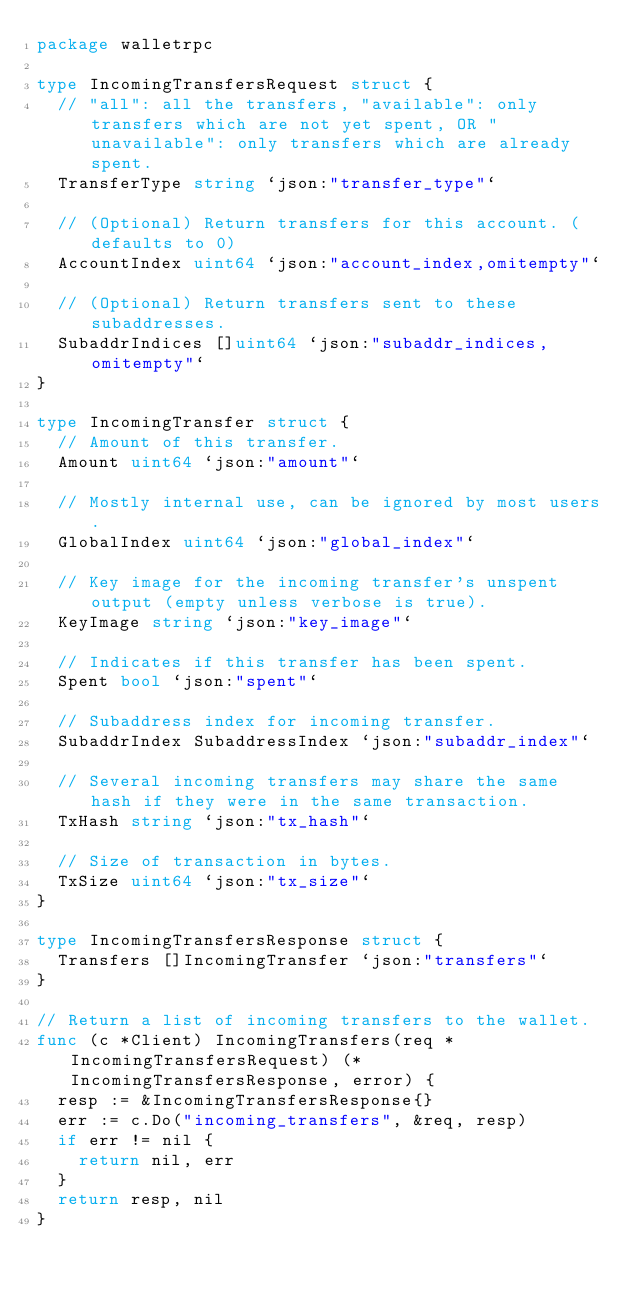Convert code to text. <code><loc_0><loc_0><loc_500><loc_500><_Go_>package walletrpc

type IncomingTransfersRequest struct {
	// "all": all the transfers, "available": only transfers which are not yet spent, OR "unavailable": only transfers which are already spent.
	TransferType string `json:"transfer_type"`

	// (Optional) Return transfers for this account. (defaults to 0)
	AccountIndex uint64 `json:"account_index,omitempty"`

	// (Optional) Return transfers sent to these subaddresses.
	SubaddrIndices []uint64 `json:"subaddr_indices,omitempty"`
}

type IncomingTransfer struct {
	// Amount of this transfer.
	Amount uint64 `json:"amount"`

	// Mostly internal use, can be ignored by most users.
	GlobalIndex uint64 `json:"global_index"`

	// Key image for the incoming transfer's unspent output (empty unless verbose is true).
	KeyImage string `json:"key_image"`

	// Indicates if this transfer has been spent.
	Spent bool `json:"spent"`

	// Subaddress index for incoming transfer.
	SubaddrIndex SubaddressIndex `json:"subaddr_index"`

	// Several incoming transfers may share the same hash if they were in the same transaction.
	TxHash string `json:"tx_hash"`

	// Size of transaction in bytes.
	TxSize uint64 `json:"tx_size"`
}

type IncomingTransfersResponse struct {
	Transfers []IncomingTransfer `json:"transfers"`
}

// Return a list of incoming transfers to the wallet.
func (c *Client) IncomingTransfers(req *IncomingTransfersRequest) (*IncomingTransfersResponse, error) {
	resp := &IncomingTransfersResponse{}
	err := c.Do("incoming_transfers", &req, resp)
	if err != nil {
		return nil, err
	}
	return resp, nil
}
</code> 